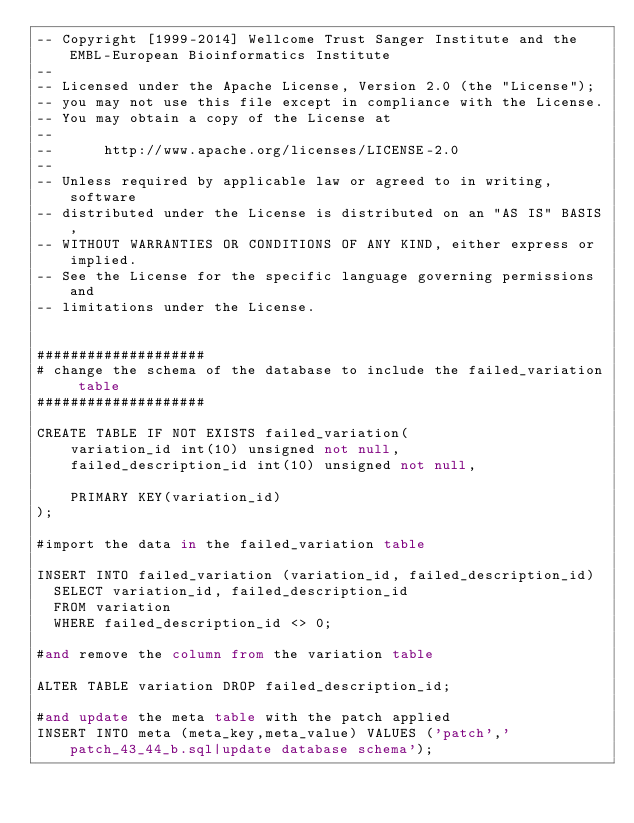<code> <loc_0><loc_0><loc_500><loc_500><_SQL_>-- Copyright [1999-2014] Wellcome Trust Sanger Institute and the EMBL-European Bioinformatics Institute
-- 
-- Licensed under the Apache License, Version 2.0 (the "License");
-- you may not use this file except in compliance with the License.
-- You may obtain a copy of the License at
-- 
--      http://www.apache.org/licenses/LICENSE-2.0
-- 
-- Unless required by applicable law or agreed to in writing, software
-- distributed under the License is distributed on an "AS IS" BASIS,
-- WITHOUT WARRANTIES OR CONDITIONS OF ANY KIND, either express or implied.
-- See the License for the specific language governing permissions and
-- limitations under the License.


####################
# change the schema of the database to include the failed_variation table
####################

CREATE TABLE IF NOT EXISTS failed_variation(
    variation_id int(10) unsigned not null,
    failed_description_id int(10) unsigned not null,

    PRIMARY KEY(variation_id)
);

#import the data in the failed_variation table

INSERT INTO failed_variation (variation_id, failed_description_id)
  SELECT variation_id, failed_description_id
  FROM variation
  WHERE failed_description_id <> 0;

#and remove the column from the variation table

ALTER TABLE variation DROP failed_description_id;

#and update the meta table with the patch applied
INSERT INTO meta (meta_key,meta_value) VALUES ('patch','patch_43_44_b.sql|update database schema');	
</code> 